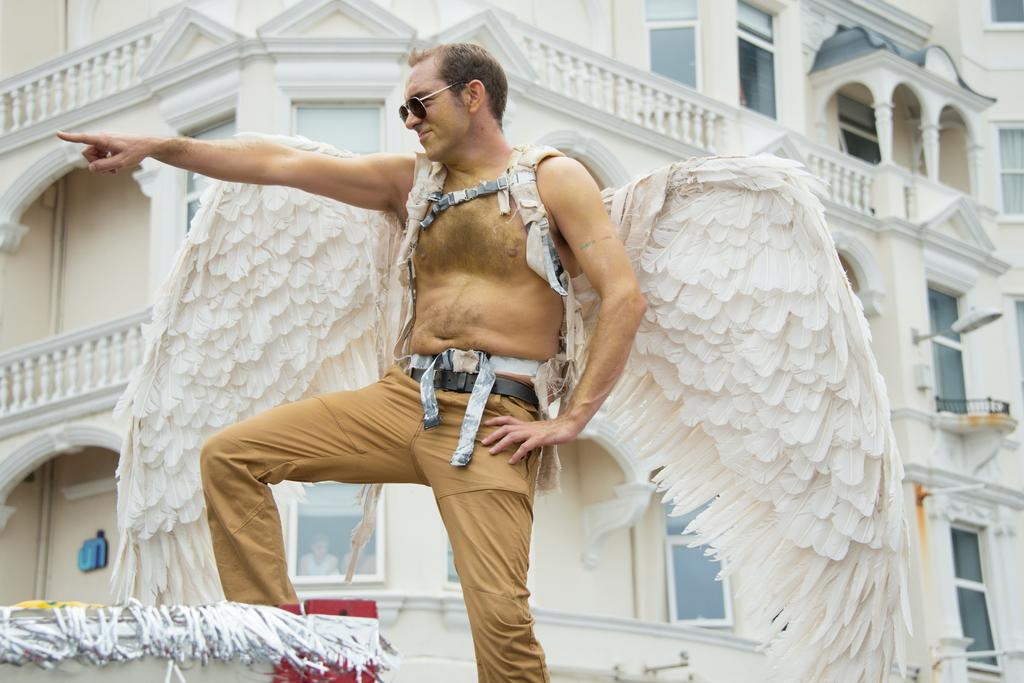What is the main subject of the image? The main subject of the image is a man. What is the man doing in the image? The man is standing in the image. What accessories is the man wearing? The man is wearing goggles and wings in the image. What type of clothing is the man wearing? The man is wearing pants in the image. What can be seen in the background of the image? There is a building in the background of the image. What type of turkey is the man holding in the image? There is no turkey present in the image. Who is the man's partner in the image? The image does not show the man with a partner. 